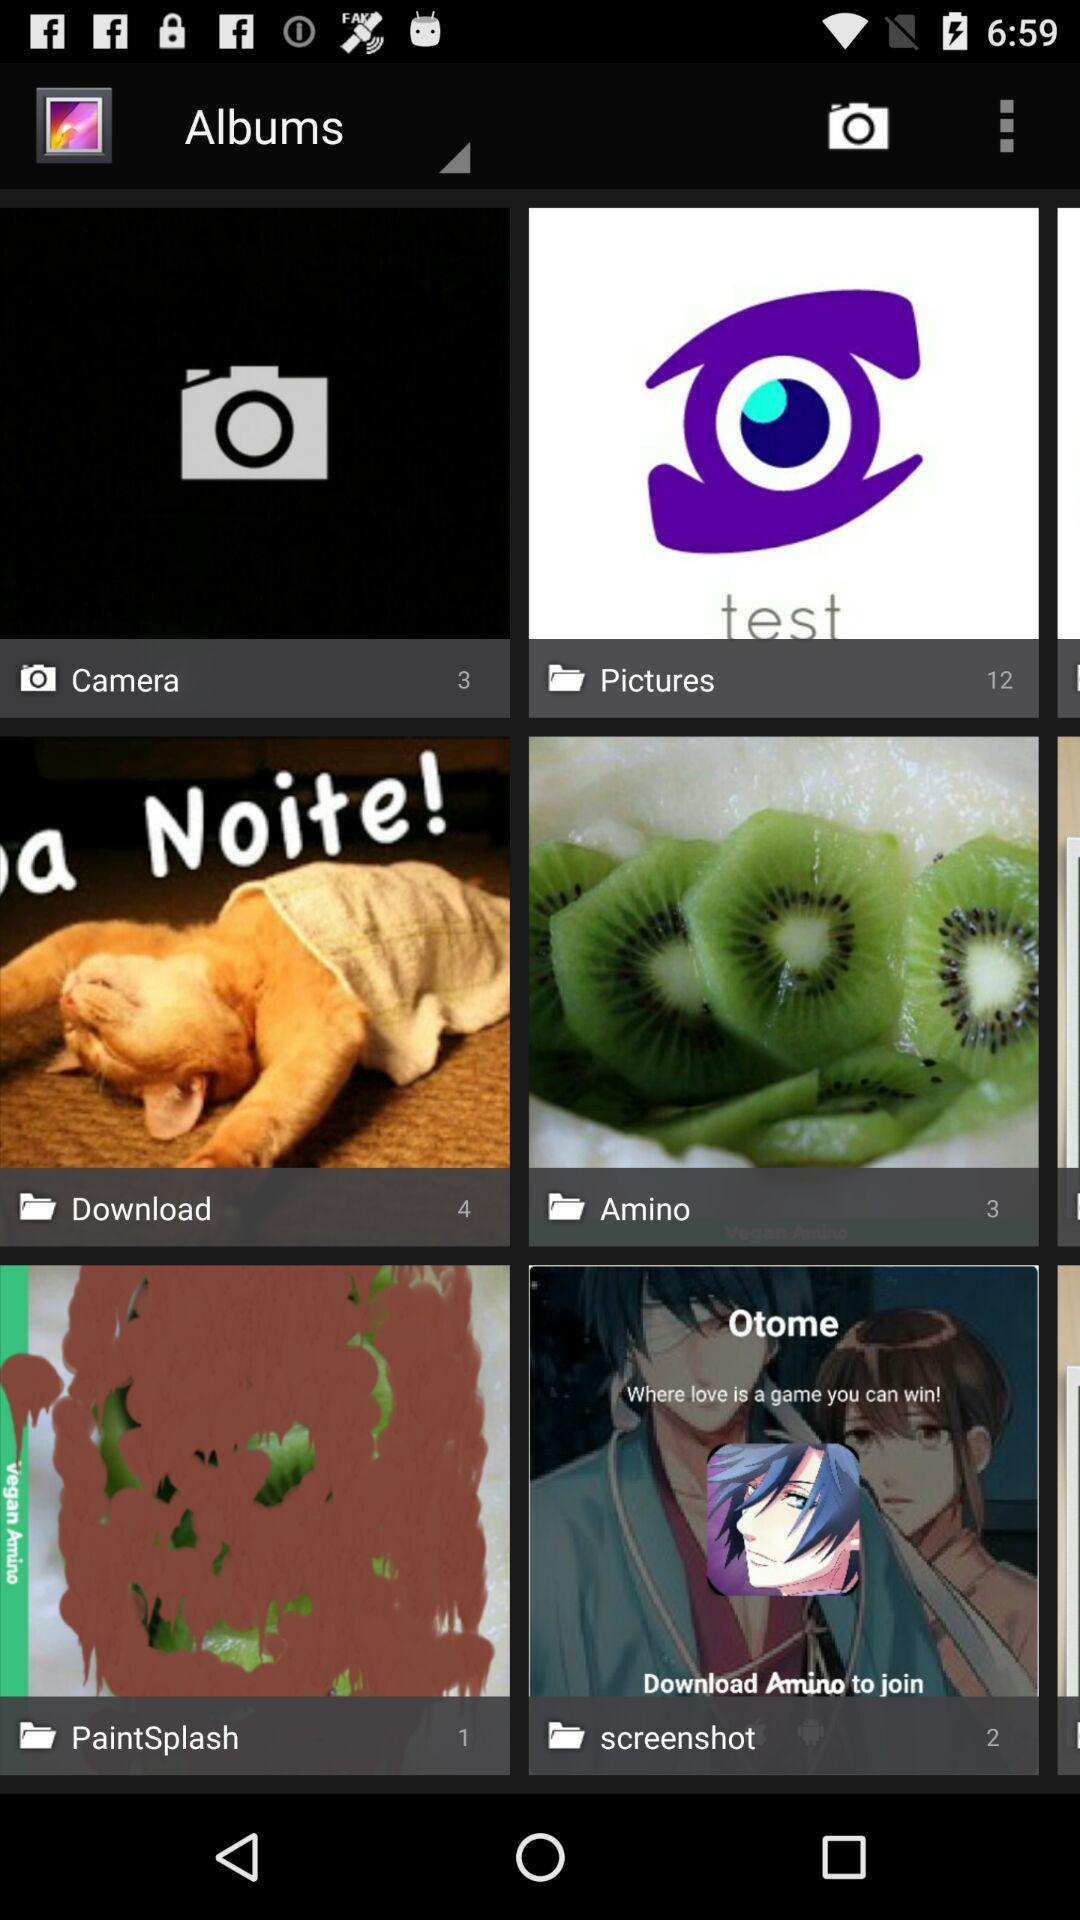How many images are there in the "Download" folder? There are 4 images in the "Download" folder. 